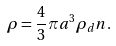Convert formula to latex. <formula><loc_0><loc_0><loc_500><loc_500>\rho = \frac { 4 } { 3 } \pi a ^ { 3 } \rho _ { d } n .</formula> 